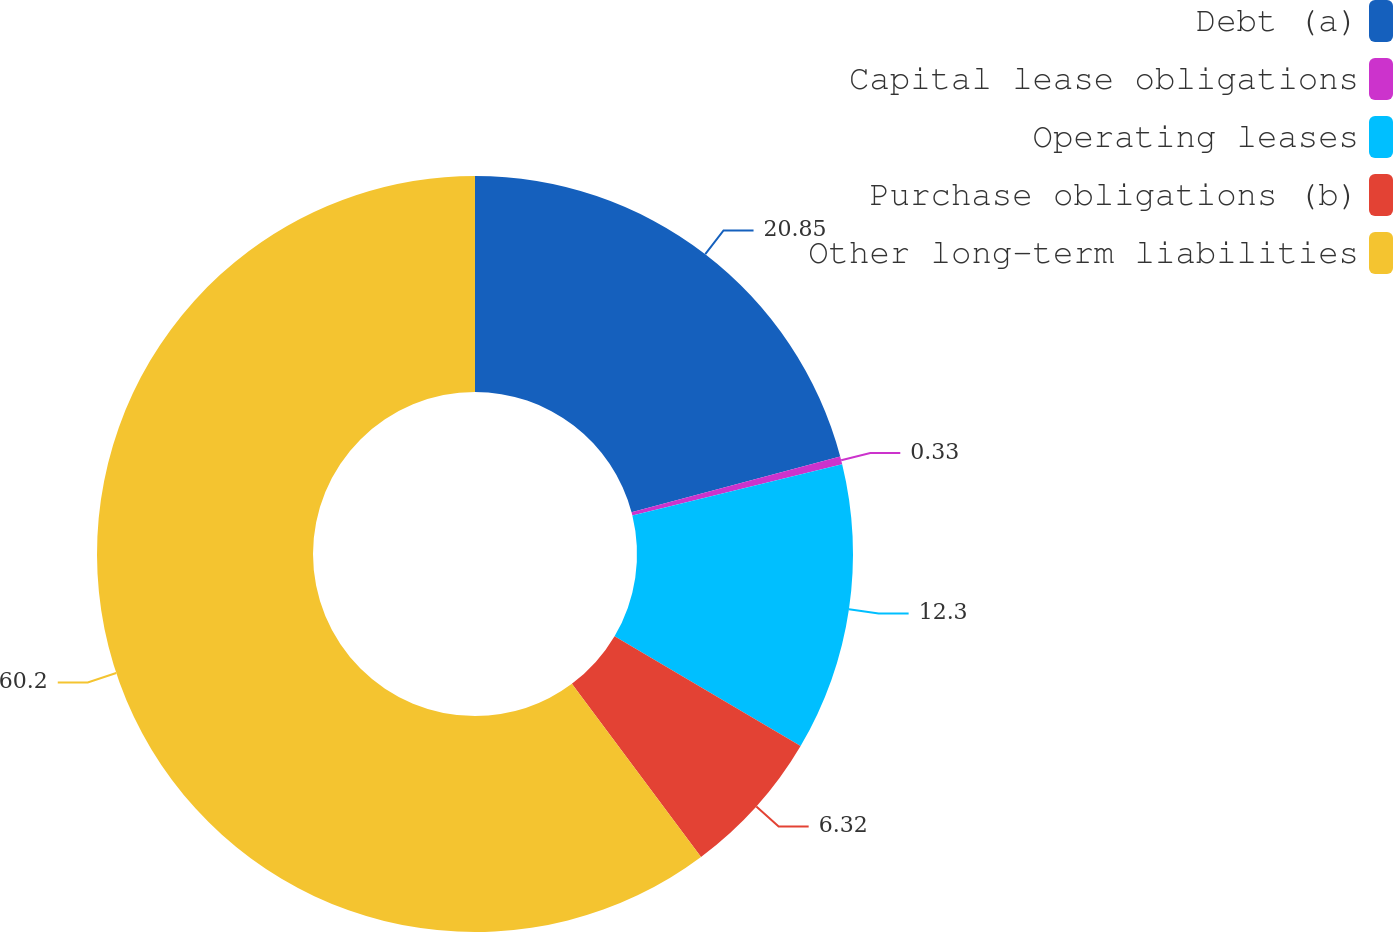Convert chart. <chart><loc_0><loc_0><loc_500><loc_500><pie_chart><fcel>Debt (a)<fcel>Capital lease obligations<fcel>Operating leases<fcel>Purchase obligations (b)<fcel>Other long-term liabilities<nl><fcel>20.85%<fcel>0.33%<fcel>12.3%<fcel>6.32%<fcel>60.2%<nl></chart> 